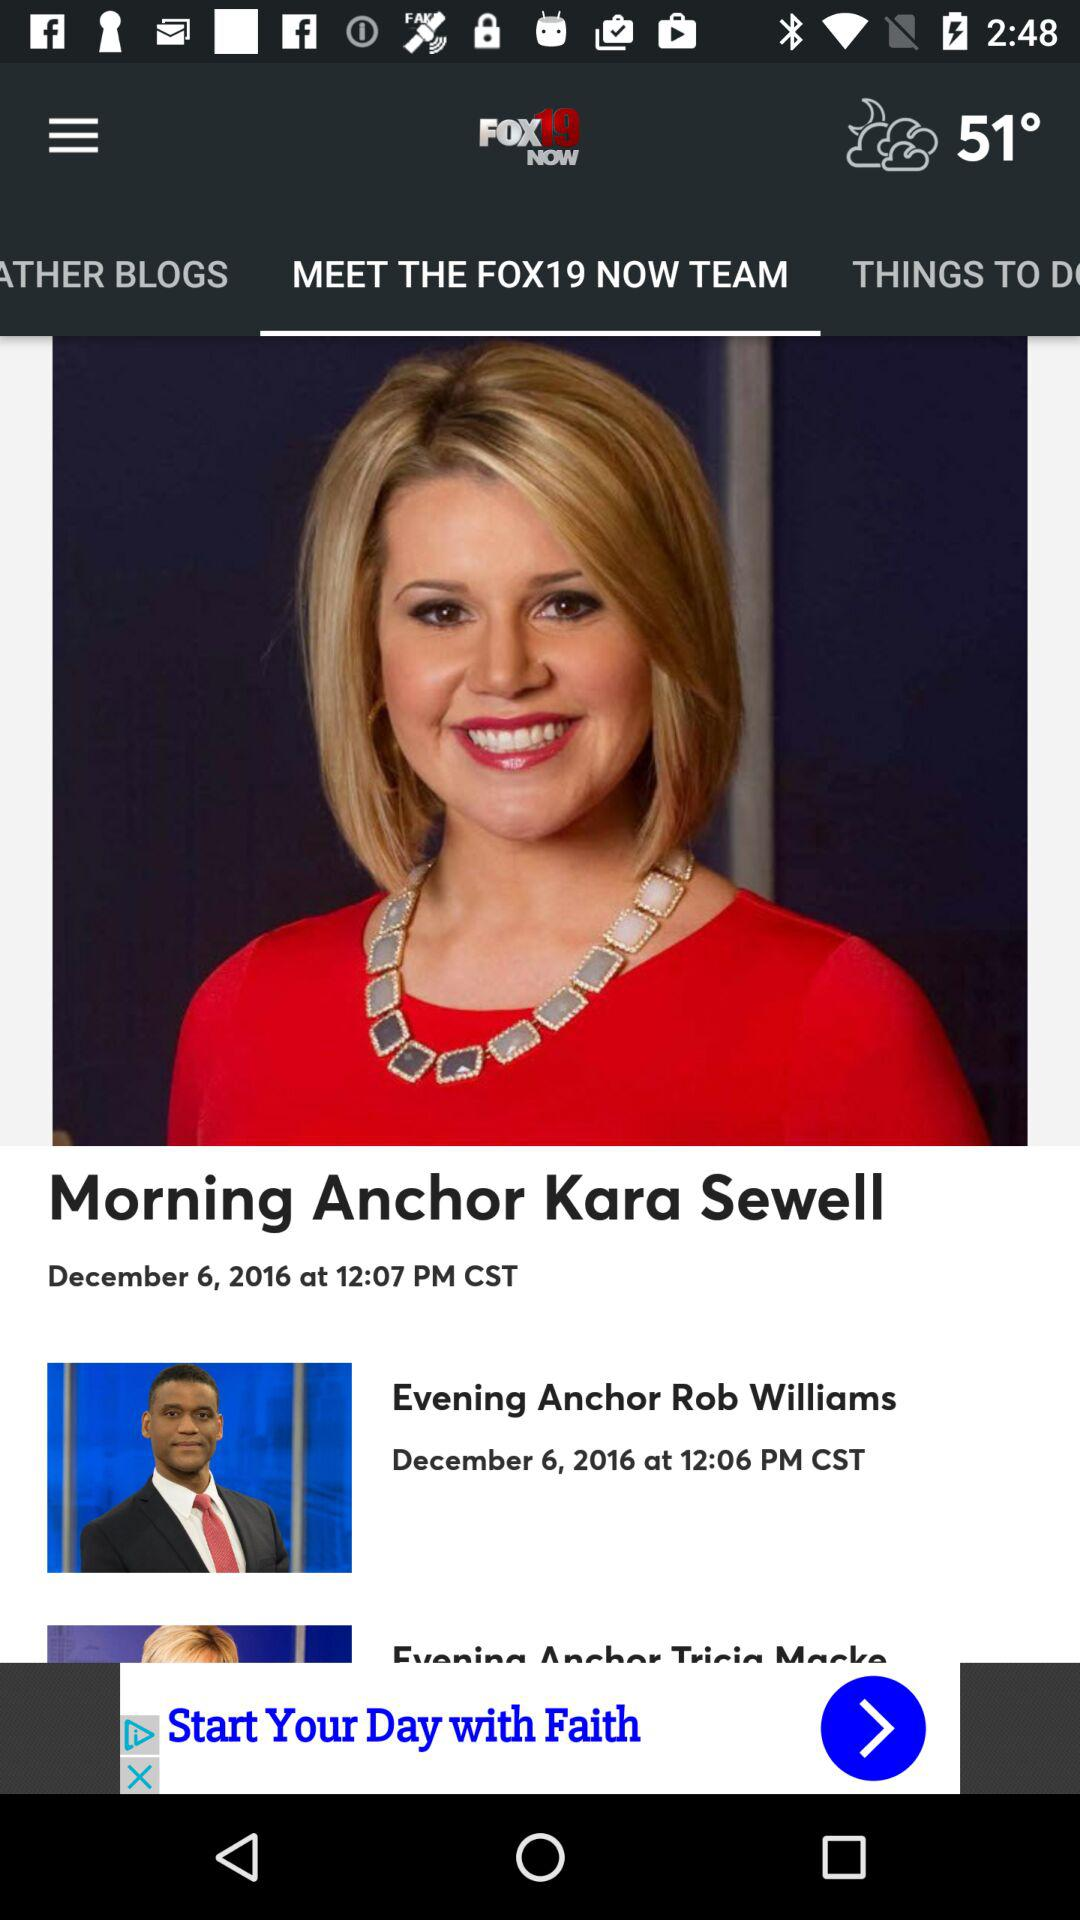What's the posting time of "Evening Anchor Rob Williams"? The posting time is 12:06 PM CST. 